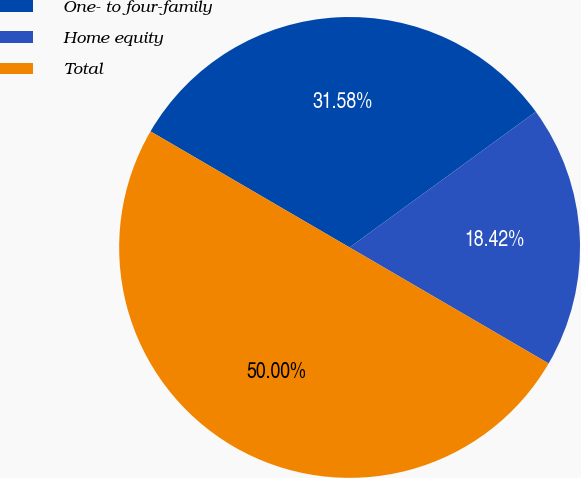Convert chart. <chart><loc_0><loc_0><loc_500><loc_500><pie_chart><fcel>One- to four-family<fcel>Home equity<fcel>Total<nl><fcel>31.58%<fcel>18.42%<fcel>50.0%<nl></chart> 